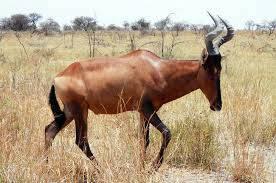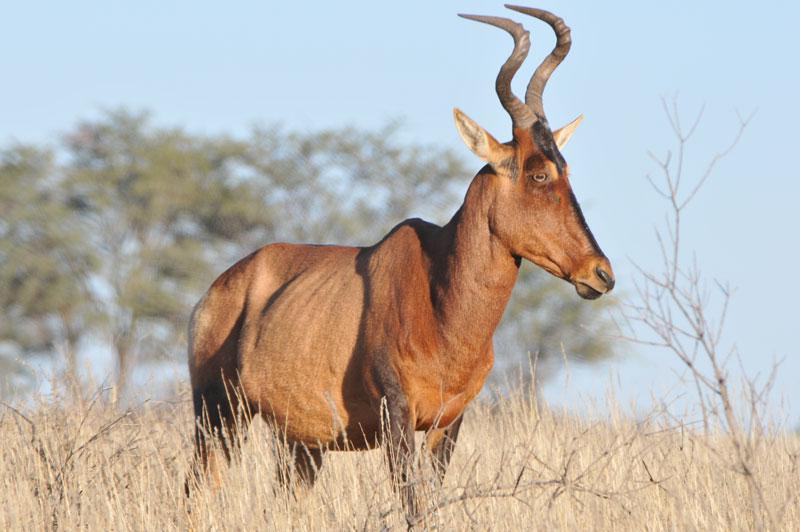The first image is the image on the left, the second image is the image on the right. For the images shown, is this caption "There is one horned mammal sitting in the left image, and multiple standing in the right." true? Answer yes or no. No. The first image is the image on the left, the second image is the image on the right. Analyze the images presented: Is the assertion "There are less than 5 animals." valid? Answer yes or no. Yes. 